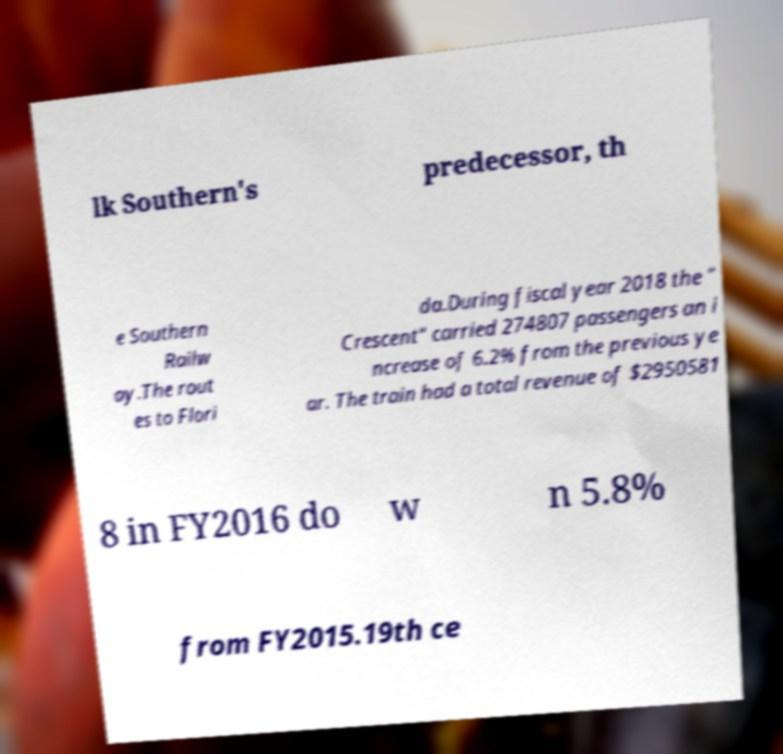Can you read and provide the text displayed in the image?This photo seems to have some interesting text. Can you extract and type it out for me? lk Southern's predecessor, th e Southern Railw ay.The rout es to Flori da.During fiscal year 2018 the " Crescent" carried 274807 passengers an i ncrease of 6.2% from the previous ye ar. The train had a total revenue of $2950581 8 in FY2016 do w n 5.8% from FY2015.19th ce 